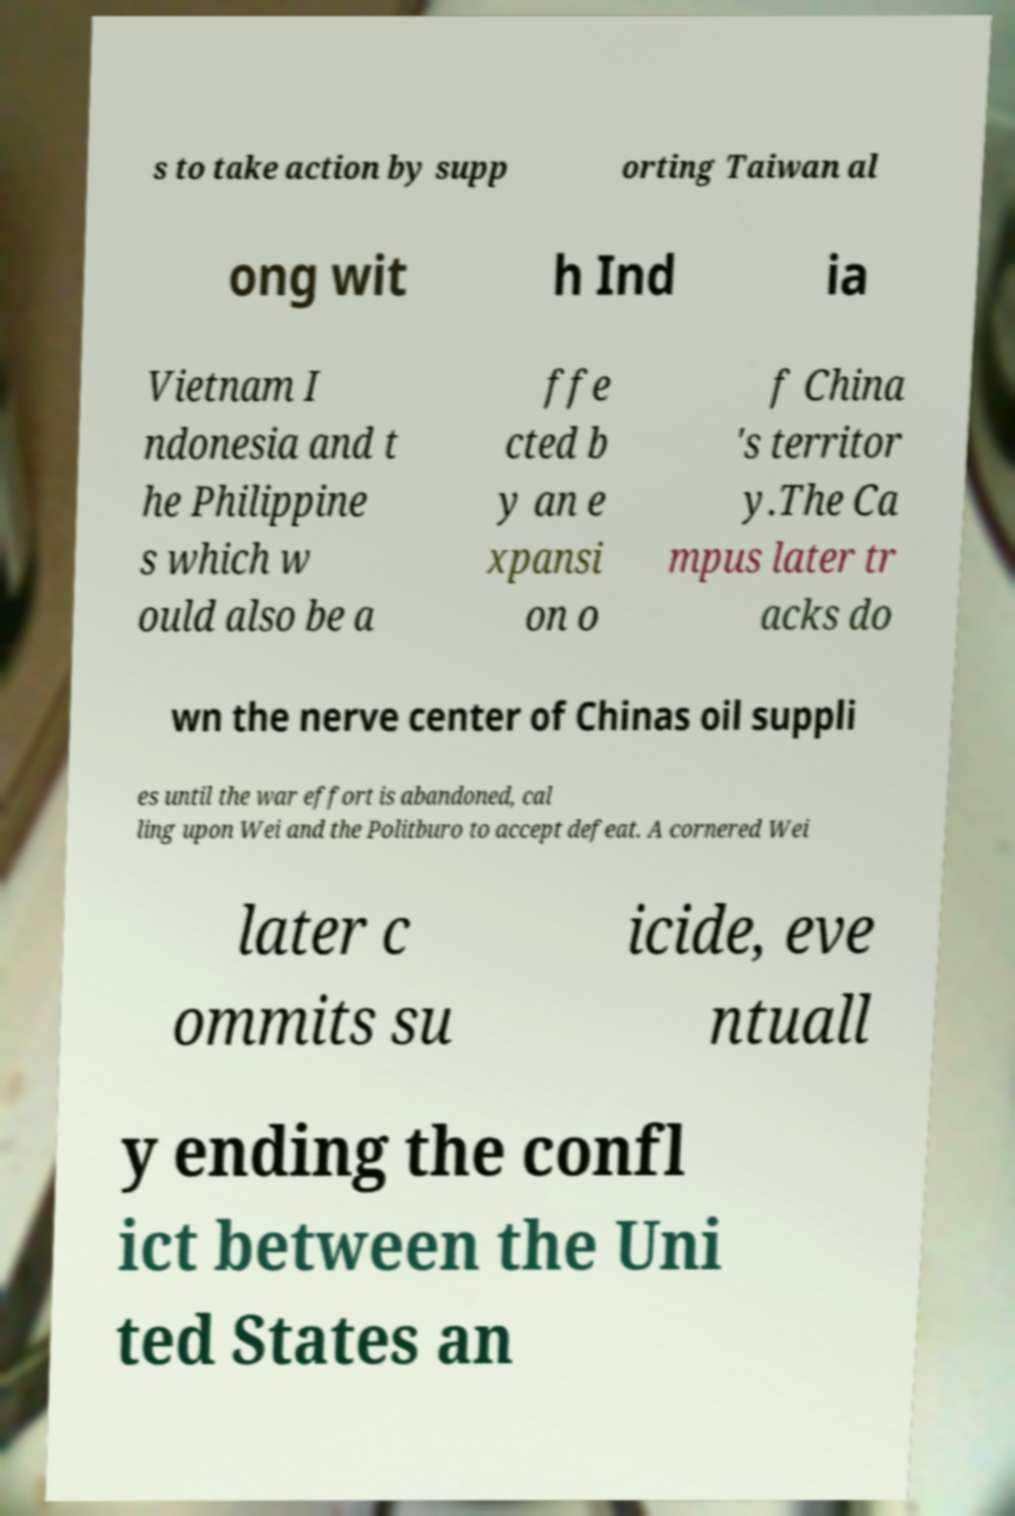For documentation purposes, I need the text within this image transcribed. Could you provide that? s to take action by supp orting Taiwan al ong wit h Ind ia Vietnam I ndonesia and t he Philippine s which w ould also be a ffe cted b y an e xpansi on o f China 's territor y.The Ca mpus later tr acks do wn the nerve center of Chinas oil suppli es until the war effort is abandoned, cal ling upon Wei and the Politburo to accept defeat. A cornered Wei later c ommits su icide, eve ntuall y ending the confl ict between the Uni ted States an 